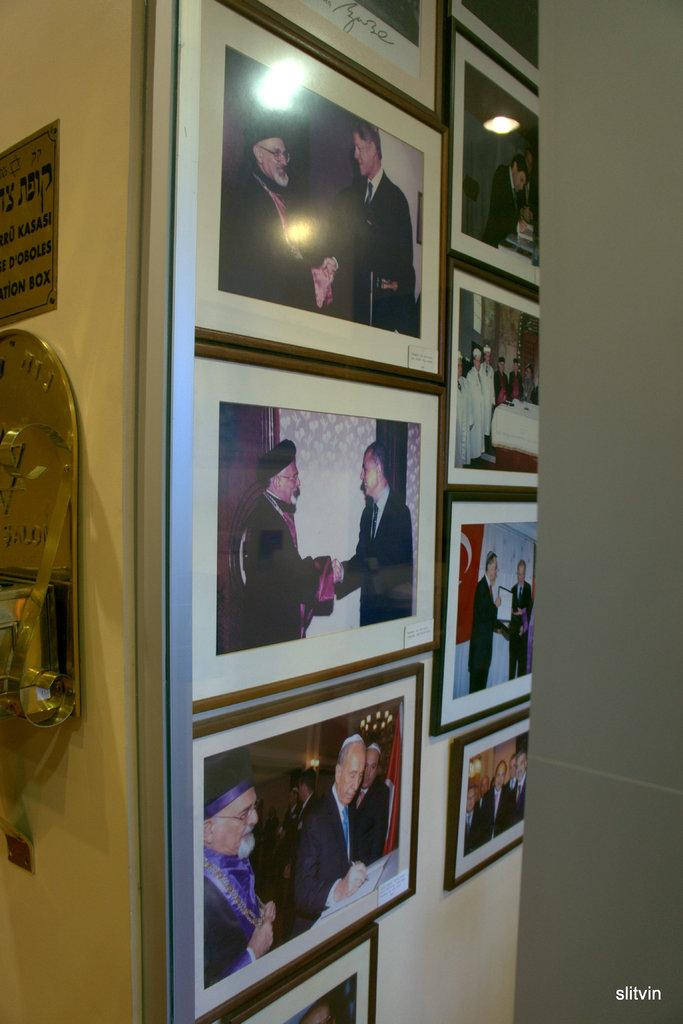What can be seen attached to the wall in the image? There are photo frames attached to the wall in the image. What other object is present in the image? There is a name board in the image. What type of pie is being served on the name board in the image? There is no pie present in the image; it only features photo frames on the wall and a name board. What amusement park can be seen in the background of the image? There is no amusement park visible in the image; it only shows photo frames on the wall and a name board. 